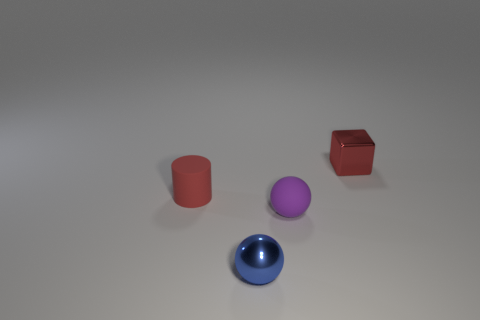Add 1 purple matte things. How many objects exist? 5 Subtract all cubes. How many objects are left? 3 Add 2 balls. How many balls exist? 4 Subtract 0 blue cylinders. How many objects are left? 4 Subtract all small metal cubes. Subtract all big red blocks. How many objects are left? 3 Add 3 small blue shiny objects. How many small blue shiny objects are left? 4 